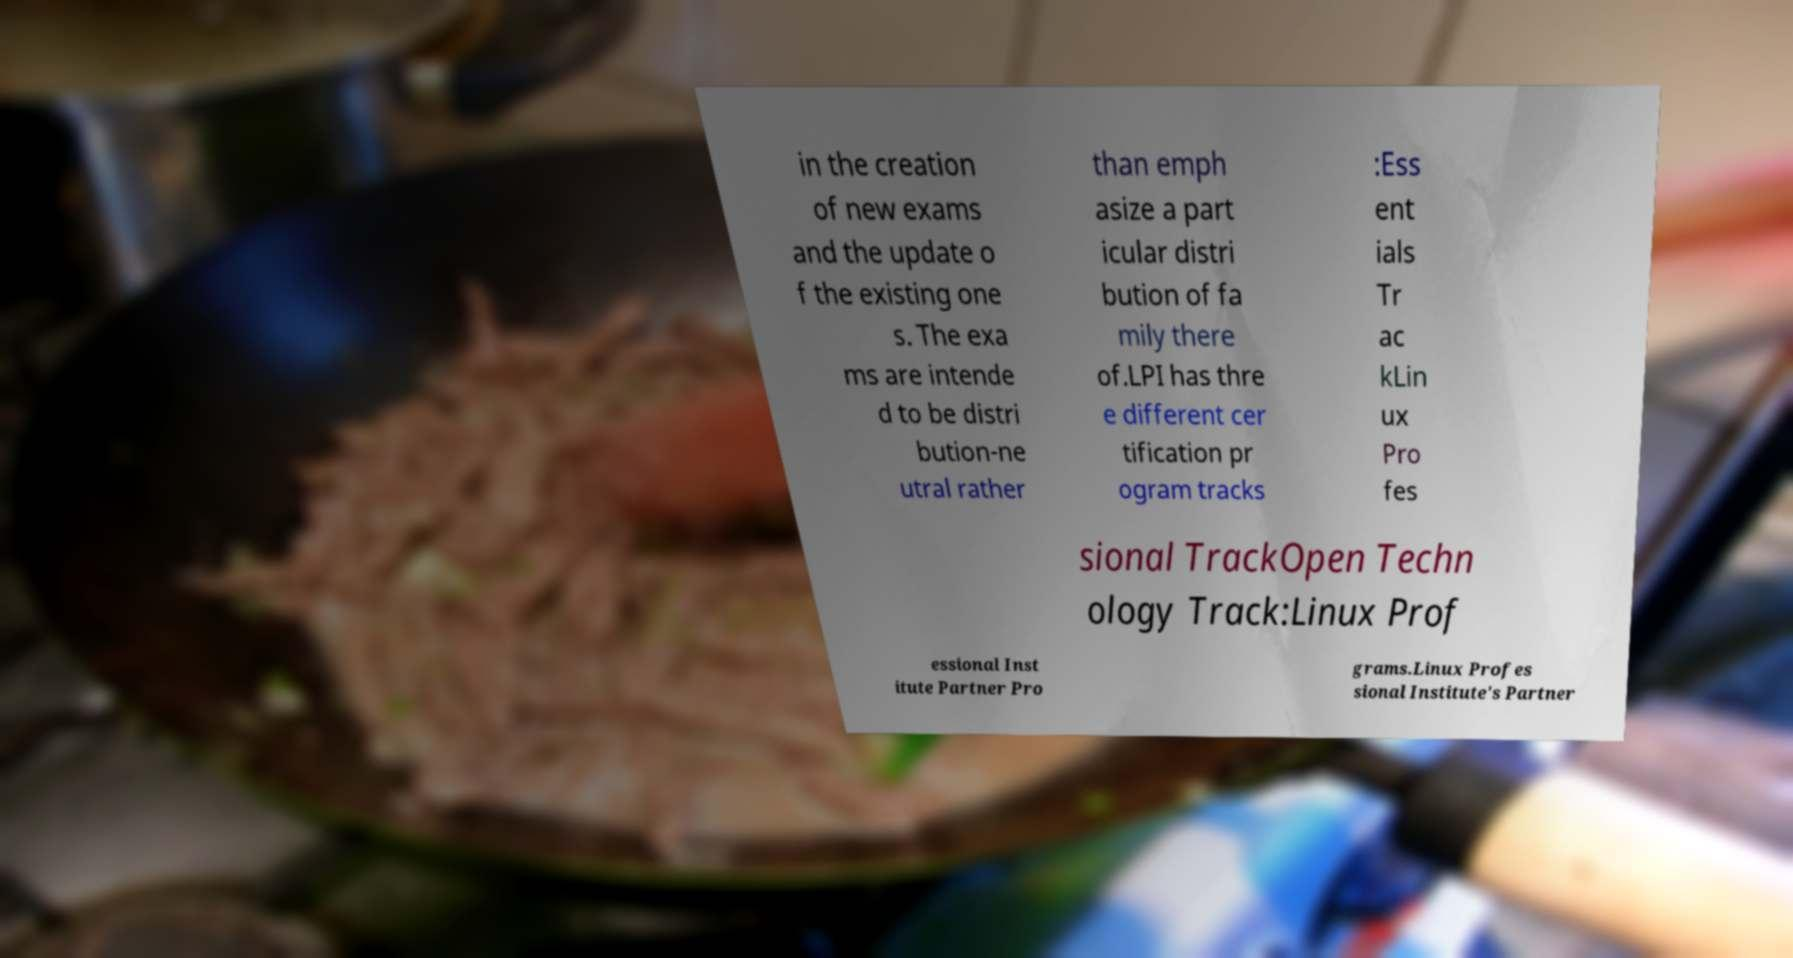I need the written content from this picture converted into text. Can you do that? in the creation of new exams and the update o f the existing one s. The exa ms are intende d to be distri bution-ne utral rather than emph asize a part icular distri bution of fa mily there of.LPI has thre e different cer tification pr ogram tracks :Ess ent ials Tr ac kLin ux Pro fes sional TrackOpen Techn ology Track:Linux Prof essional Inst itute Partner Pro grams.Linux Profes sional Institute's Partner 